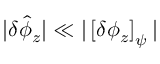Convert formula to latex. <formula><loc_0><loc_0><loc_500><loc_500>| \delta \hat { \phi } _ { z } | \ll | \left [ \delta \phi _ { z } \right ] _ { \psi } |</formula> 